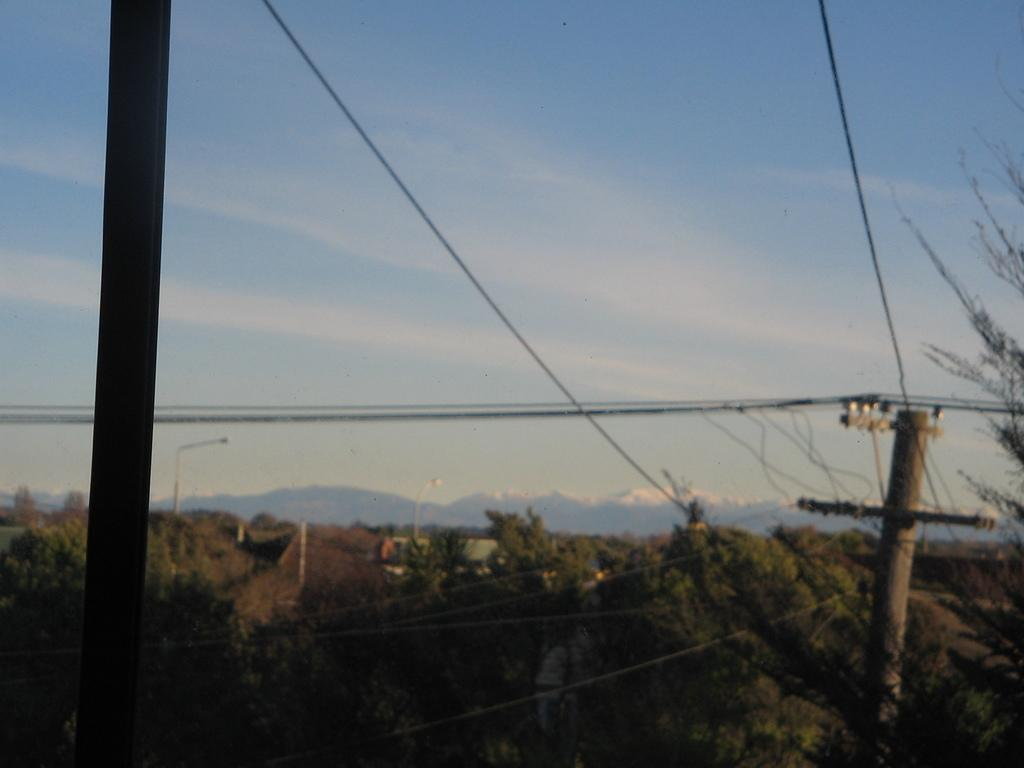What structures can be seen in the image? There are poles and wires in the image. What else is present in the image besides the poles and wires? There are trees in the image. What can be seen in the background of the image? The sky is visible in the background of the image. What type of skirt is hanging from the wire in the image? There is no skirt present in the image; it features poles, wires, and trees. 